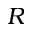<formula> <loc_0><loc_0><loc_500><loc_500>R</formula> 